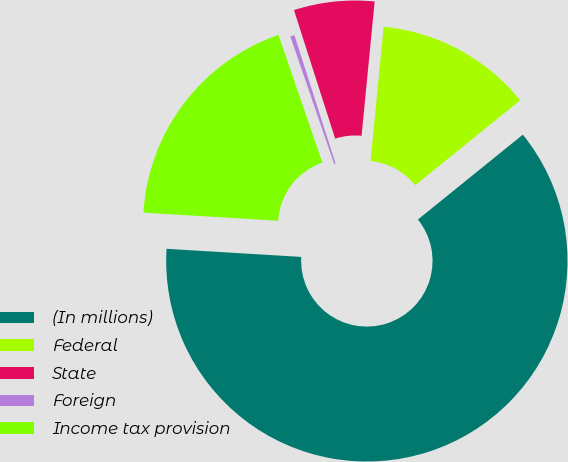<chart> <loc_0><loc_0><loc_500><loc_500><pie_chart><fcel>(In millions)<fcel>Federal<fcel>State<fcel>Foreign<fcel>Income tax provision<nl><fcel>61.78%<fcel>12.63%<fcel>6.48%<fcel>0.34%<fcel>18.77%<nl></chart> 